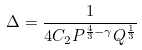<formula> <loc_0><loc_0><loc_500><loc_500>\Delta = \frac { 1 } { 4 C _ { 2 } P ^ { \frac { 4 } { 3 } - \gamma } Q ^ { \frac { 1 } { 3 } } }</formula> 